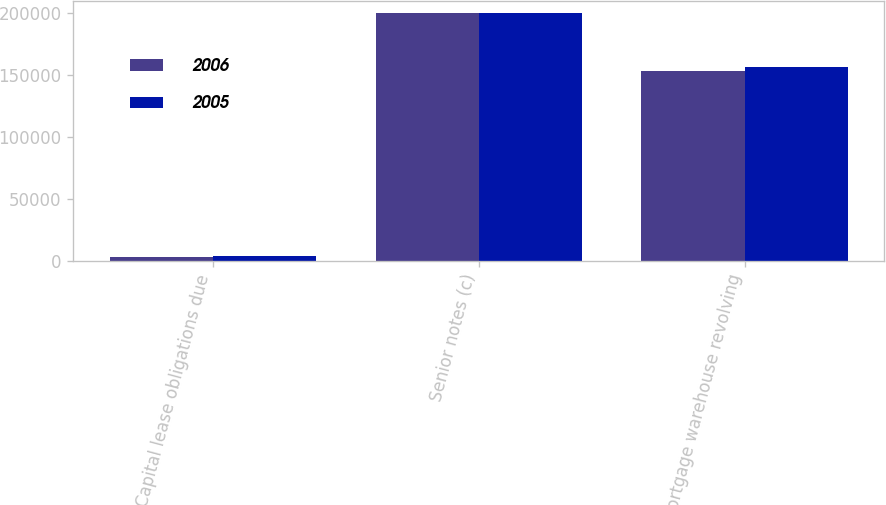Convert chart. <chart><loc_0><loc_0><loc_500><loc_500><stacked_bar_chart><ecel><fcel>Capital lease obligations due<fcel>Senior notes (c)<fcel>Mortgage warehouse revolving<nl><fcel>2006<fcel>3080<fcel>200000<fcel>153552<nl><fcel>2005<fcel>3325<fcel>200000<fcel>156816<nl></chart> 